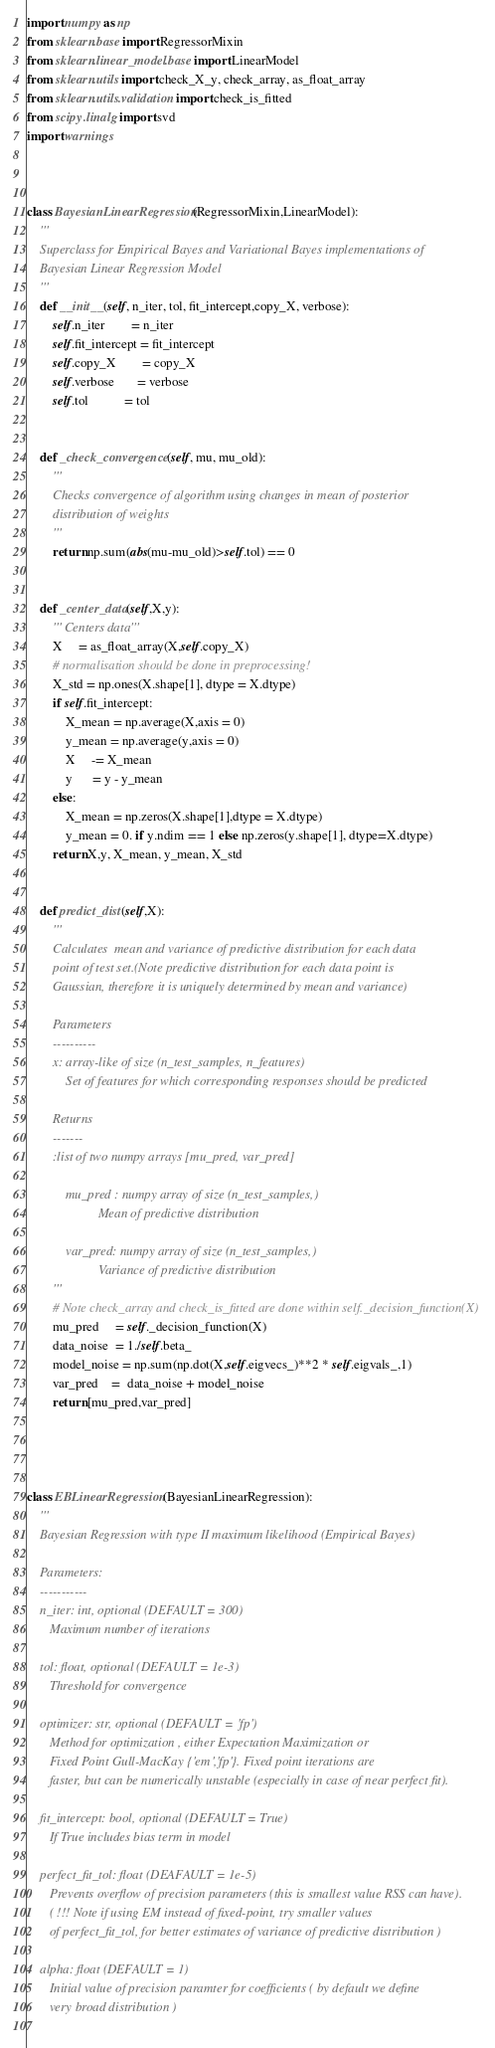<code> <loc_0><loc_0><loc_500><loc_500><_Python_>import numpy as np
from sklearn.base import RegressorMixin
from sklearn.linear_model.base import LinearModel
from sklearn.utils import check_X_y, check_array, as_float_array
from sklearn.utils.validation import check_is_fitted
from scipy.linalg import svd
import warnings



class BayesianLinearRegression(RegressorMixin,LinearModel):
    '''
    Superclass for Empirical Bayes and Variational Bayes implementations of 
    Bayesian Linear Regression Model
    '''
    def __init__(self, n_iter, tol, fit_intercept,copy_X, verbose):
        self.n_iter        = n_iter
        self.fit_intercept = fit_intercept
        self.copy_X        = copy_X
        self.verbose       = verbose
        self.tol           = tol
        
        
    def _check_convergence(self, mu, mu_old):
        '''
        Checks convergence of algorithm using changes in mean of posterior
        distribution of weights
        '''
        return np.sum(abs(mu-mu_old)>self.tol) == 0
        
        
    def _center_data(self,X,y):
        ''' Centers data'''
        X     = as_float_array(X,self.copy_X)
        # normalisation should be done in preprocessing!
        X_std = np.ones(X.shape[1], dtype = X.dtype)
        if self.fit_intercept:
            X_mean = np.average(X,axis = 0)
            y_mean = np.average(y,axis = 0)
            X     -= X_mean
            y      = y - y_mean
        else:
            X_mean = np.zeros(X.shape[1],dtype = X.dtype)
            y_mean = 0. if y.ndim == 1 else np.zeros(y.shape[1], dtype=X.dtype)
        return X,y, X_mean, y_mean, X_std
        
        
    def predict_dist(self,X):
        '''
        Calculates  mean and variance of predictive distribution for each data 
        point of test set.(Note predictive distribution for each data point is 
        Gaussian, therefore it is uniquely determined by mean and variance)                    
                    
        Parameters
        ----------
        x: array-like of size (n_test_samples, n_features)
            Set of features for which corresponding responses should be predicted

        Returns
        -------
        :list of two numpy arrays [mu_pred, var_pred]
        
            mu_pred : numpy array of size (n_test_samples,)
                      Mean of predictive distribution
                      
            var_pred: numpy array of size (n_test_samples,)
                      Variance of predictive distribution        
        '''
        # Note check_array and check_is_fitted are done within self._decision_function(X)
        mu_pred     = self._decision_function(X)
        data_noise  = 1./self.beta_
        model_noise = np.sum(np.dot(X,self.eigvecs_)**2 * self.eigvals_,1)
        var_pred    =  data_noise + model_noise
        return [mu_pred,var_pred]
    
        
        

class EBLinearRegression(BayesianLinearRegression):
    '''
    Bayesian Regression with type II maximum likelihood (Empirical Bayes)
    
    Parameters:
    -----------  
    n_iter: int, optional (DEFAULT = 300)
       Maximum number of iterations
         
    tol: float, optional (DEFAULT = 1e-3)
       Threshold for convergence
       
    optimizer: str, optional (DEFAULT = 'fp')
       Method for optimization , either Expectation Maximization or 
       Fixed Point Gull-MacKay {'em','fp'}. Fixed point iterations are
       faster, but can be numerically unstable (especially in case of near perfect fit).
       
    fit_intercept: bool, optional (DEFAULT = True)
       If True includes bias term in model
       
    perfect_fit_tol: float (DEAFAULT = 1e-5)
       Prevents overflow of precision parameters (this is smallest value RSS can have).
       ( !!! Note if using EM instead of fixed-point, try smaller values
       of perfect_fit_tol, for better estimates of variance of predictive distribution )

    alpha: float (DEFAULT = 1)
       Initial value of precision paramter for coefficients ( by default we define 
       very broad distribution )
       </code> 